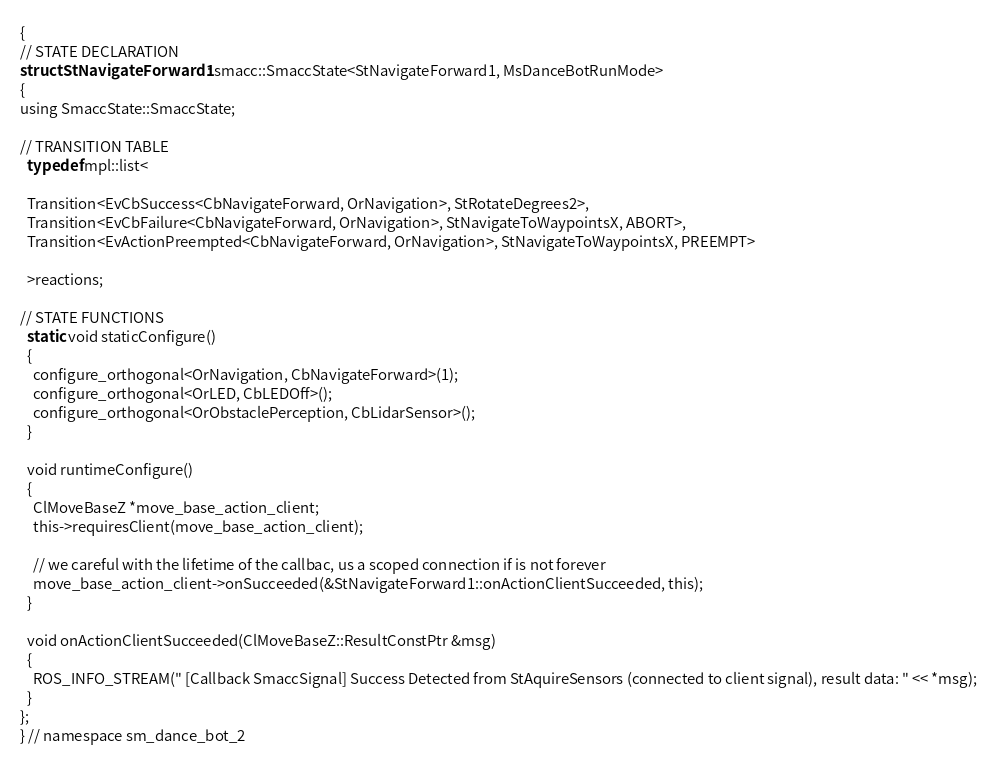<code> <loc_0><loc_0><loc_500><loc_500><_C_>{
// STATE DECLARATION
struct StNavigateForward1 : smacc::SmaccState<StNavigateForward1, MsDanceBotRunMode>
{
using SmaccState::SmaccState;

// TRANSITION TABLE
  typedef mpl::list<

  Transition<EvCbSuccess<CbNavigateForward, OrNavigation>, StRotateDegrees2>,
  Transition<EvCbFailure<CbNavigateForward, OrNavigation>, StNavigateToWaypointsX, ABORT>,
  Transition<EvActionPreempted<CbNavigateForward, OrNavigation>, StNavigateToWaypointsX, PREEMPT>
  
  >reactions;

// STATE FUNCTIONS
  static void staticConfigure()
  {
    configure_orthogonal<OrNavigation, CbNavigateForward>(1);
    configure_orthogonal<OrLED, CbLEDOff>();
    configure_orthogonal<OrObstaclePerception, CbLidarSensor>();
  }

  void runtimeConfigure()
  {
    ClMoveBaseZ *move_base_action_client;
    this->requiresClient(move_base_action_client);

    // we careful with the lifetime of the callbac, us a scoped connection if is not forever
    move_base_action_client->onSucceeded(&StNavigateForward1::onActionClientSucceeded, this);
  }

  void onActionClientSucceeded(ClMoveBaseZ::ResultConstPtr &msg)
  {
    ROS_INFO_STREAM(" [Callback SmaccSignal] Success Detected from StAquireSensors (connected to client signal), result data: " << *msg);
  }
};
} // namespace sm_dance_bot_2</code> 